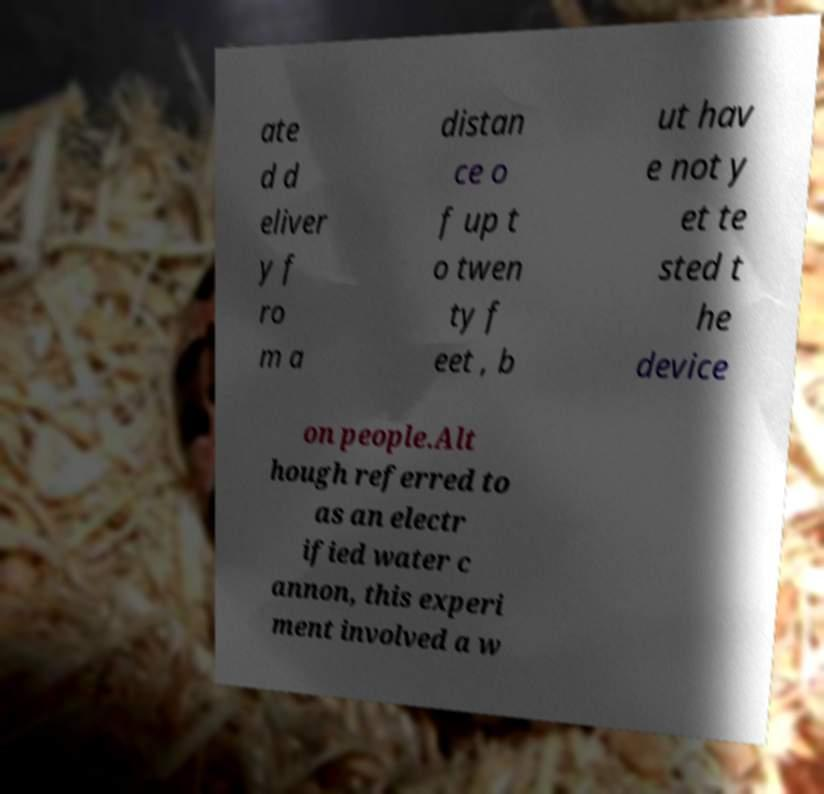Please read and relay the text visible in this image. What does it say? ate d d eliver y f ro m a distan ce o f up t o twen ty f eet , b ut hav e not y et te sted t he device on people.Alt hough referred to as an electr ified water c annon, this experi ment involved a w 